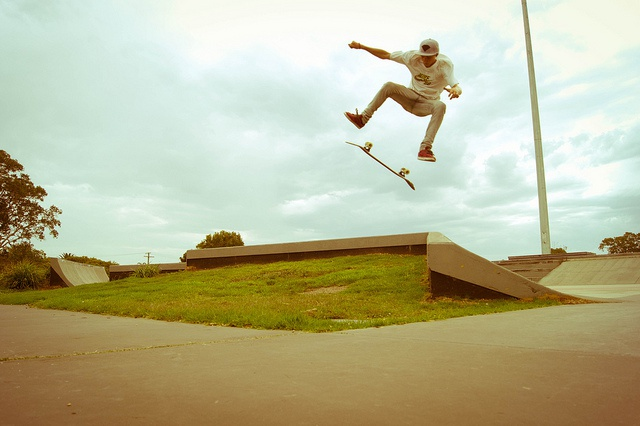Describe the objects in this image and their specific colors. I can see people in lightblue, tan, olive, and maroon tones and skateboard in lightblue, ivory, maroon, olive, and tan tones in this image. 